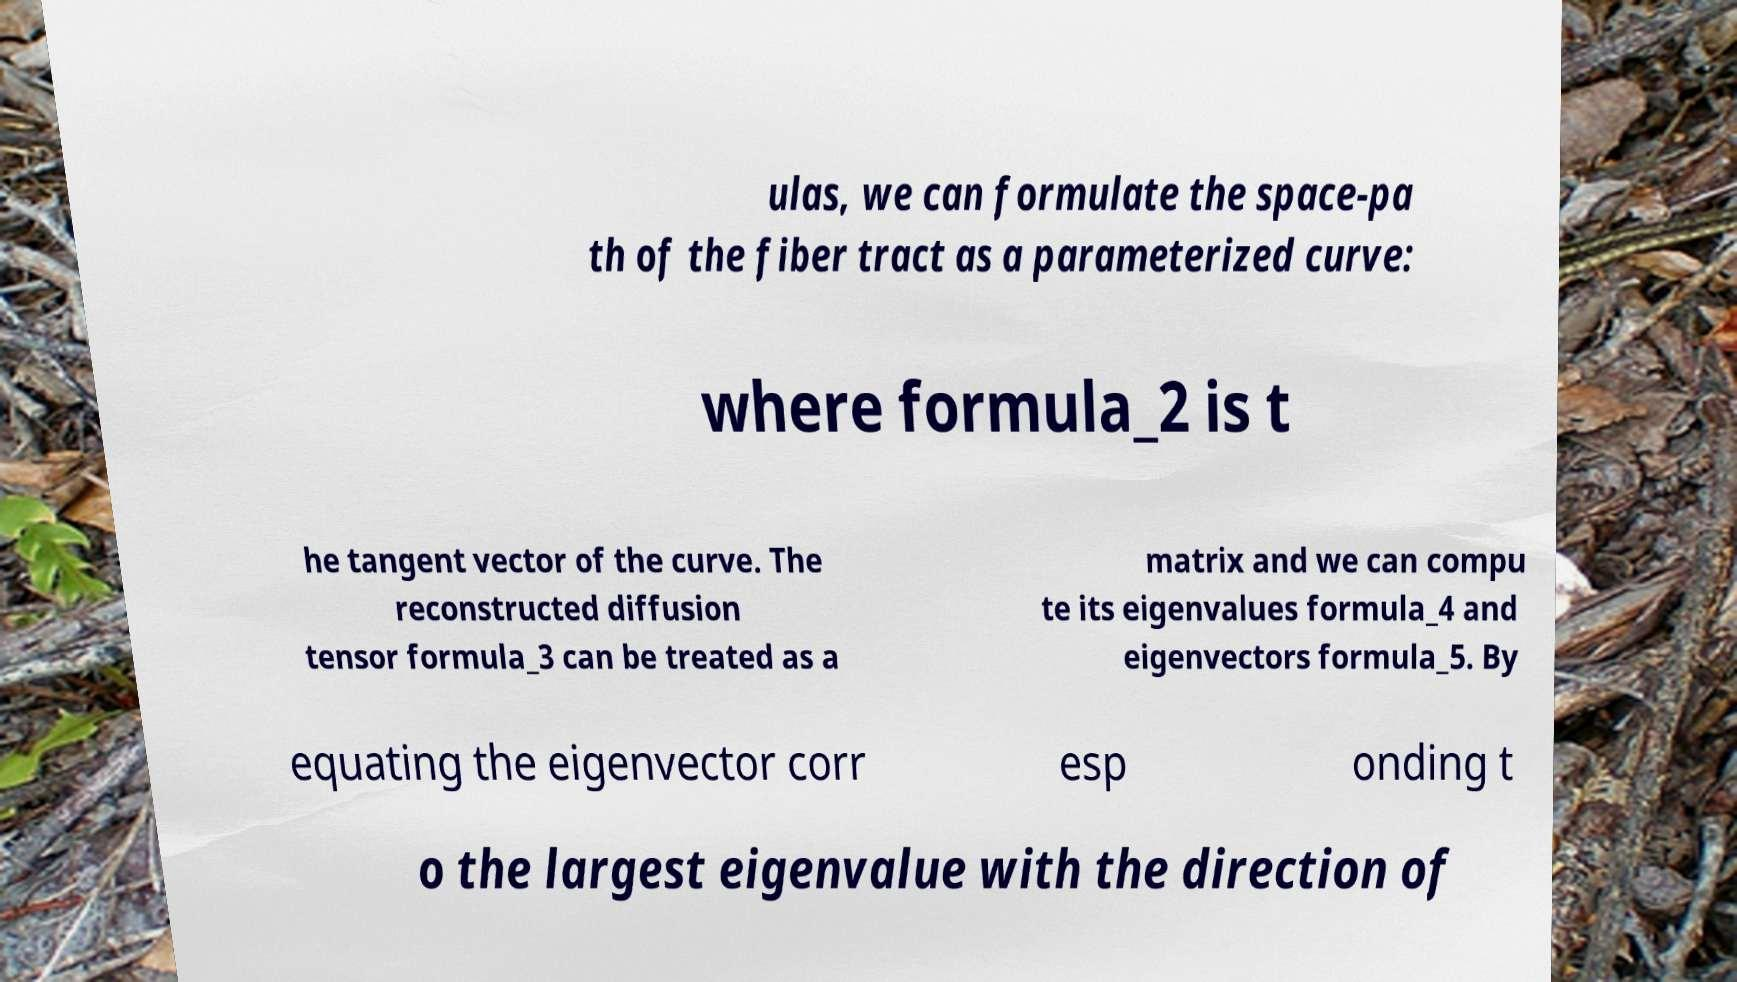I need the written content from this picture converted into text. Can you do that? ulas, we can formulate the space-pa th of the fiber tract as a parameterized curve: where formula_2 is t he tangent vector of the curve. The reconstructed diffusion tensor formula_3 can be treated as a matrix and we can compu te its eigenvalues formula_4 and eigenvectors formula_5. By equating the eigenvector corr esp onding t o the largest eigenvalue with the direction of 